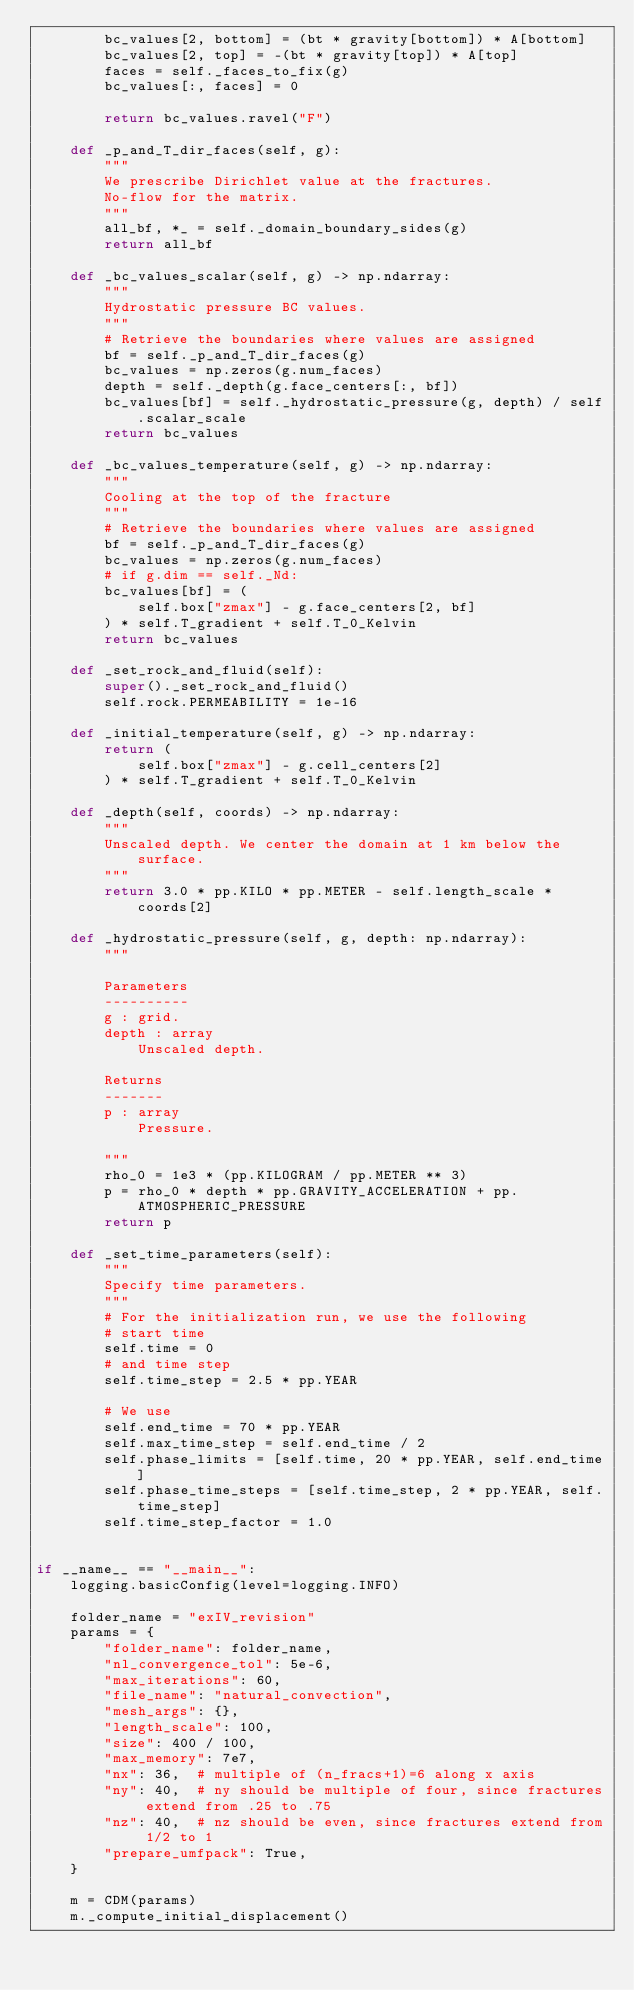Convert code to text. <code><loc_0><loc_0><loc_500><loc_500><_Python_>        bc_values[2, bottom] = (bt * gravity[bottom]) * A[bottom]
        bc_values[2, top] = -(bt * gravity[top]) * A[top]
        faces = self._faces_to_fix(g)
        bc_values[:, faces] = 0

        return bc_values.ravel("F")

    def _p_and_T_dir_faces(self, g):
        """
        We prescribe Dirichlet value at the fractures.
        No-flow for the matrix.
        """
        all_bf, *_ = self._domain_boundary_sides(g)
        return all_bf

    def _bc_values_scalar(self, g) -> np.ndarray:
        """
        Hydrostatic pressure BC values.
        """
        # Retrieve the boundaries where values are assigned
        bf = self._p_and_T_dir_faces(g)
        bc_values = np.zeros(g.num_faces)
        depth = self._depth(g.face_centers[:, bf])
        bc_values[bf] = self._hydrostatic_pressure(g, depth) / self.scalar_scale
        return bc_values

    def _bc_values_temperature(self, g) -> np.ndarray:
        """
        Cooling at the top of the fracture
        """
        # Retrieve the boundaries where values are assigned
        bf = self._p_and_T_dir_faces(g)
        bc_values = np.zeros(g.num_faces)
        # if g.dim == self._Nd:
        bc_values[bf] = (
            self.box["zmax"] - g.face_centers[2, bf]
        ) * self.T_gradient + self.T_0_Kelvin
        return bc_values

    def _set_rock_and_fluid(self):
        super()._set_rock_and_fluid()
        self.rock.PERMEABILITY = 1e-16

    def _initial_temperature(self, g) -> np.ndarray:
        return (
            self.box["zmax"] - g.cell_centers[2]
        ) * self.T_gradient + self.T_0_Kelvin

    def _depth(self, coords) -> np.ndarray:
        """
        Unscaled depth. We center the domain at 1 km below the surface.
        """
        return 3.0 * pp.KILO * pp.METER - self.length_scale * coords[2]

    def _hydrostatic_pressure(self, g, depth: np.ndarray):
        """

        Parameters
        ----------
        g : grid.
        depth : array
            Unscaled depth.

        Returns
        -------
        p : array
            Pressure.

        """
        rho_0 = 1e3 * (pp.KILOGRAM / pp.METER ** 3)
        p = rho_0 * depth * pp.GRAVITY_ACCELERATION + pp.ATMOSPHERIC_PRESSURE
        return p

    def _set_time_parameters(self):
        """
        Specify time parameters.
        """
        # For the initialization run, we use the following
        # start time
        self.time = 0
        # and time step
        self.time_step = 2.5 * pp.YEAR

        # We use
        self.end_time = 70 * pp.YEAR
        self.max_time_step = self.end_time / 2
        self.phase_limits = [self.time, 20 * pp.YEAR, self.end_time]
        self.phase_time_steps = [self.time_step, 2 * pp.YEAR, self.time_step]
        self.time_step_factor = 1.0


if __name__ == "__main__":
    logging.basicConfig(level=logging.INFO)

    folder_name = "exIV_revision"
    params = {
        "folder_name": folder_name,
        "nl_convergence_tol": 5e-6,
        "max_iterations": 60,
        "file_name": "natural_convection",
        "mesh_args": {},
        "length_scale": 100,
        "size": 400 / 100,
        "max_memory": 7e7,
        "nx": 36,  # multiple of (n_fracs+1)=6 along x axis
        "ny": 40,  # ny should be multiple of four, since fractures extend from .25 to .75
        "nz": 40,  # nz should be even, since fractures extend from 1/2 to 1
        "prepare_umfpack": True,
    }

    m = CDM(params)
    m._compute_initial_displacement()</code> 